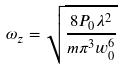Convert formula to latex. <formula><loc_0><loc_0><loc_500><loc_500>\omega _ { z } = \sqrt { \frac { 8 P _ { 0 } \lambda ^ { 2 } } { m \pi ^ { 3 } w _ { 0 } ^ { 6 } } }</formula> 